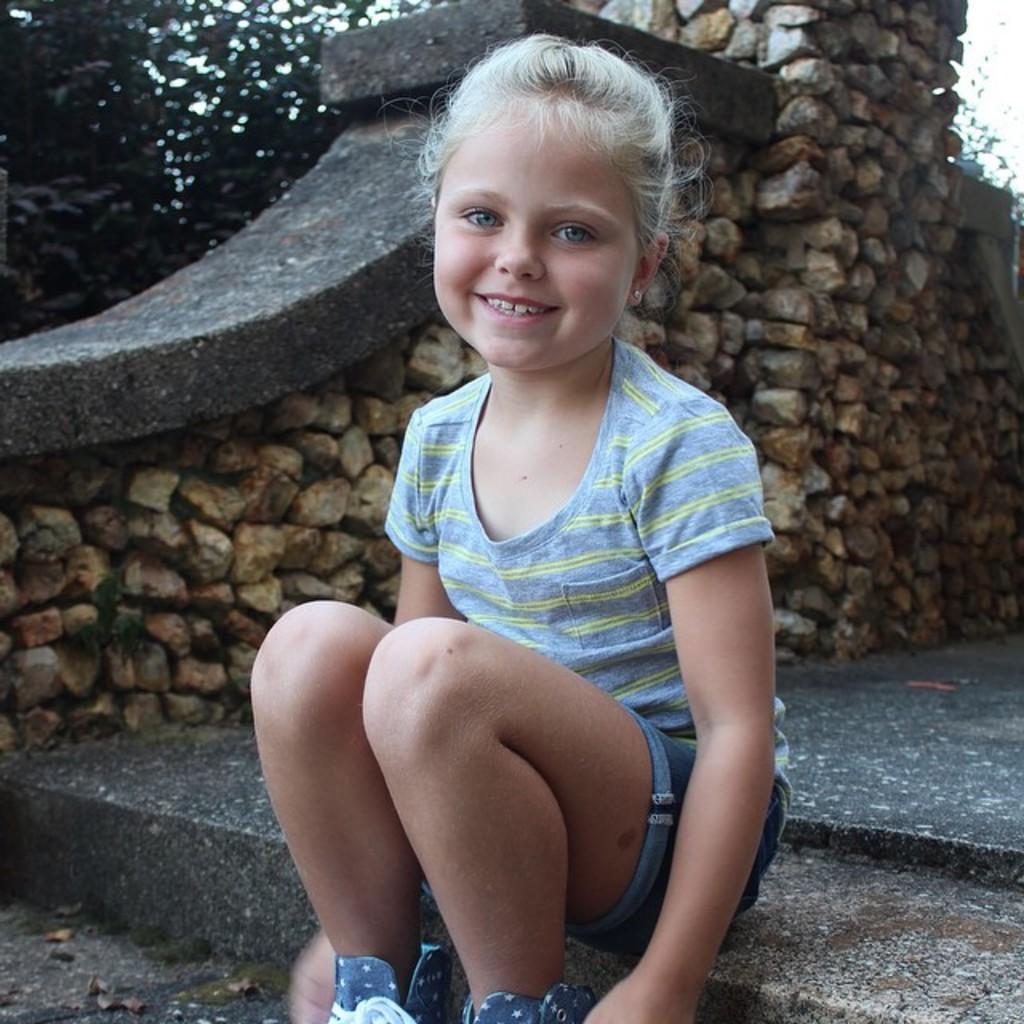Could you give a brief overview of what you see in this image? This is a girl sitting and smiling. In the background, I think this is a wall, which is built with the rocks. This looks like a tree. 